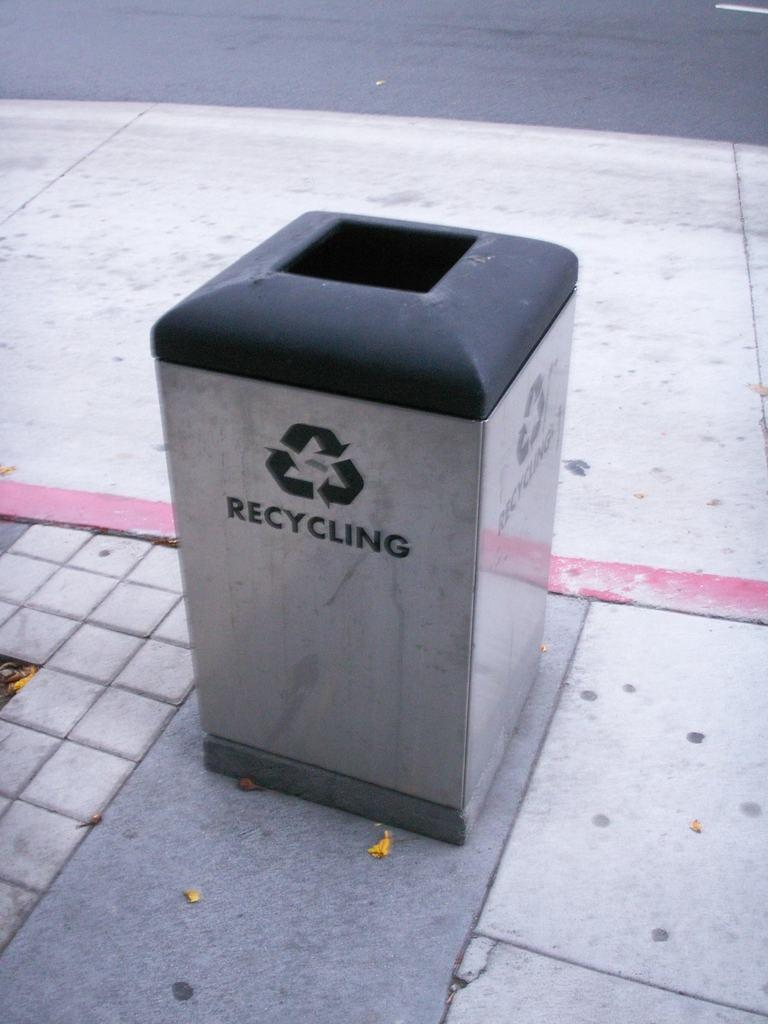<image>
Provide a brief description of the given image. a Recycling silver and black bin on a street somewhere 